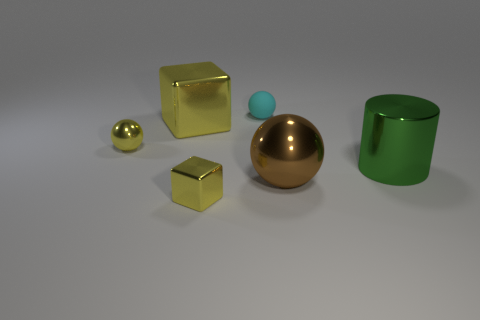Is the rubber object the same shape as the big brown metallic thing?
Offer a very short reply. Yes. There is another block that is the same color as the small shiny block; what material is it?
Your answer should be very brief. Metal. Do the small shiny ball and the big block have the same color?
Your response must be concise. Yes. There is a block that is in front of the small metal object that is on the left side of the yellow shiny block that is in front of the big shiny block; what is it made of?
Provide a short and direct response. Metal. The brown metal object that is the same shape as the cyan rubber thing is what size?
Offer a terse response. Large. Is there anything else that has the same material as the cyan ball?
Offer a terse response. No. Is there anything else that is the same color as the matte thing?
Provide a succinct answer. No. There is a green object that is made of the same material as the big brown ball; what size is it?
Make the answer very short. Large. How many metallic objects are the same size as the rubber object?
Offer a terse response. 2. What is the shape of the small metal object that is the same color as the small metal block?
Offer a very short reply. Sphere. 